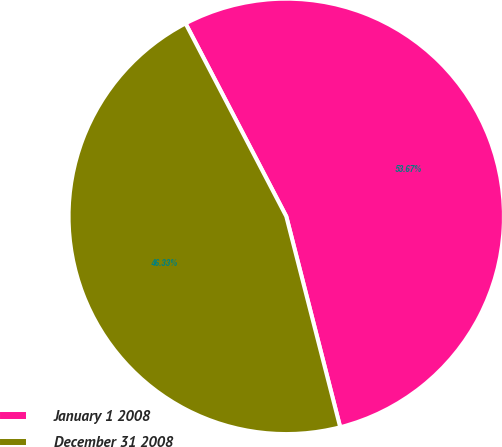<chart> <loc_0><loc_0><loc_500><loc_500><pie_chart><fcel>January 1 2008<fcel>December 31 2008<nl><fcel>53.67%<fcel>46.33%<nl></chart> 